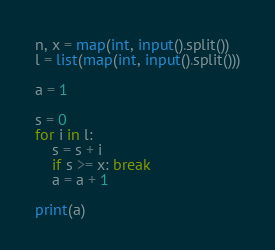<code> <loc_0><loc_0><loc_500><loc_500><_Python_>n, x = map(int, input().split())
l = list(map(int, input().split()))

a = 1

s = 0
for i in l:
    s = s + i
    if s >= x: break
    a = a + 1

print(a)

</code> 